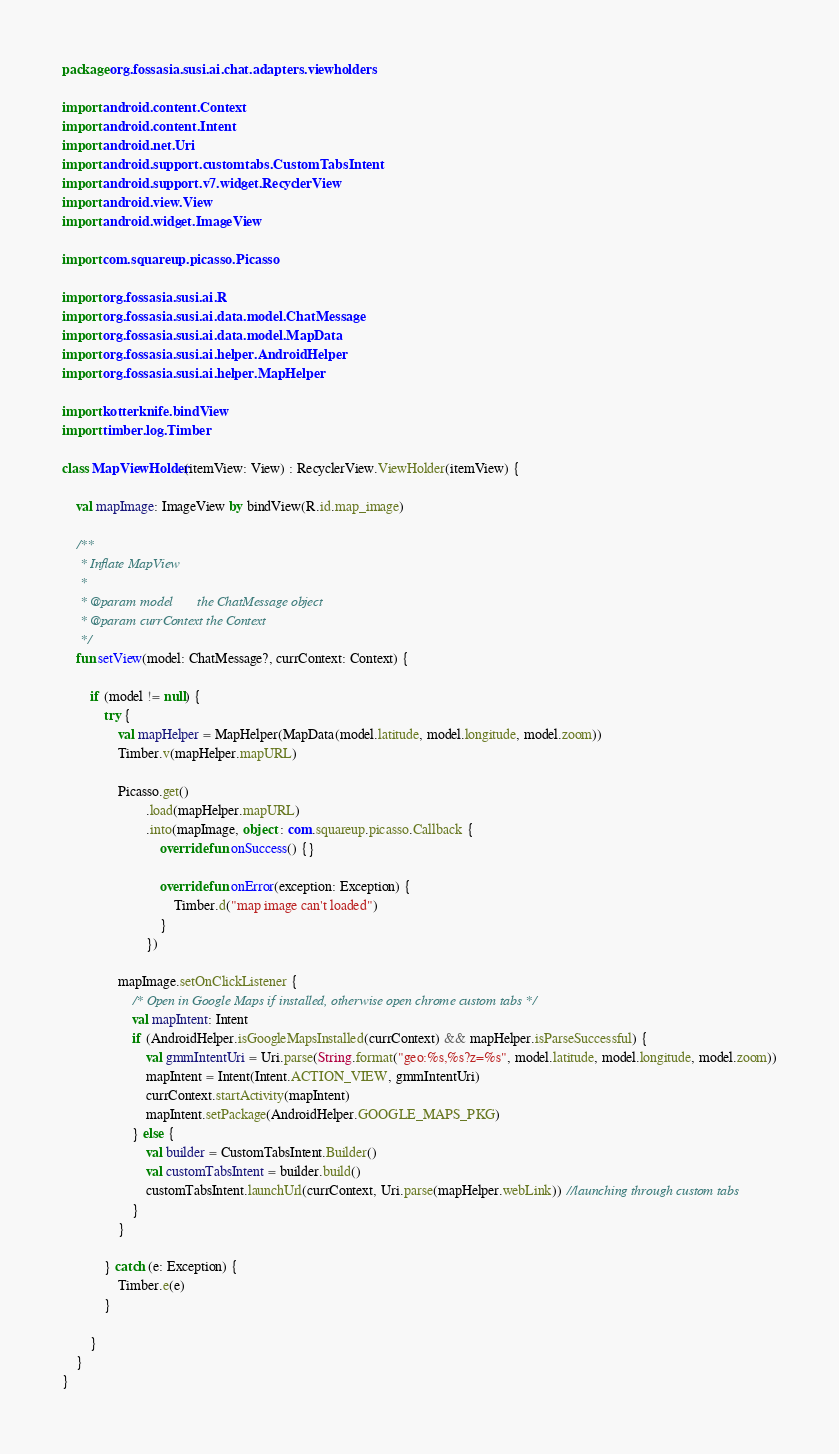Convert code to text. <code><loc_0><loc_0><loc_500><loc_500><_Kotlin_>package org.fossasia.susi.ai.chat.adapters.viewholders

import android.content.Context
import android.content.Intent
import android.net.Uri
import android.support.customtabs.CustomTabsIntent
import android.support.v7.widget.RecyclerView
import android.view.View
import android.widget.ImageView

import com.squareup.picasso.Picasso

import org.fossasia.susi.ai.R
import org.fossasia.susi.ai.data.model.ChatMessage
import org.fossasia.susi.ai.data.model.MapData
import org.fossasia.susi.ai.helper.AndroidHelper
import org.fossasia.susi.ai.helper.MapHelper

import kotterknife.bindView
import timber.log.Timber

class MapViewHolder(itemView: View) : RecyclerView.ViewHolder(itemView) {

    val mapImage: ImageView by bindView(R.id.map_image)

    /**
     * Inflate MapView
     *
     * @param model       the ChatMessage object
     * @param currContext the Context
     */
    fun setView(model: ChatMessage?, currContext: Context) {

        if (model != null) {
            try {
                val mapHelper = MapHelper(MapData(model.latitude, model.longitude, model.zoom))
                Timber.v(mapHelper.mapURL)

                Picasso.get()
                        .load(mapHelper.mapURL)
                        .into(mapImage, object : com.squareup.picasso.Callback {
                            override fun onSuccess() {}

                            override fun onError(exception: Exception) {
                                Timber.d("map image can't loaded")
                            }
                        })

                mapImage.setOnClickListener {
                    /* Open in Google Maps if installed, otherwise open chrome custom tabs */
                    val mapIntent: Intent
                    if (AndroidHelper.isGoogleMapsInstalled(currContext) && mapHelper.isParseSuccessful) {
                        val gmmIntentUri = Uri.parse(String.format("geo:%s,%s?z=%s", model.latitude, model.longitude, model.zoom))
                        mapIntent = Intent(Intent.ACTION_VIEW, gmmIntentUri)
                        currContext.startActivity(mapIntent)
                        mapIntent.setPackage(AndroidHelper.GOOGLE_MAPS_PKG)
                    } else {
                        val builder = CustomTabsIntent.Builder()
                        val customTabsIntent = builder.build()
                        customTabsIntent.launchUrl(currContext, Uri.parse(mapHelper.webLink)) //launching through custom tabs
                    }
                }

            } catch (e: Exception) {
                Timber.e(e)
            }

        }
    }
}
</code> 